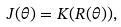<formula> <loc_0><loc_0><loc_500><loc_500>J ( \theta ) = K ( R ( \theta ) ) ,</formula> 